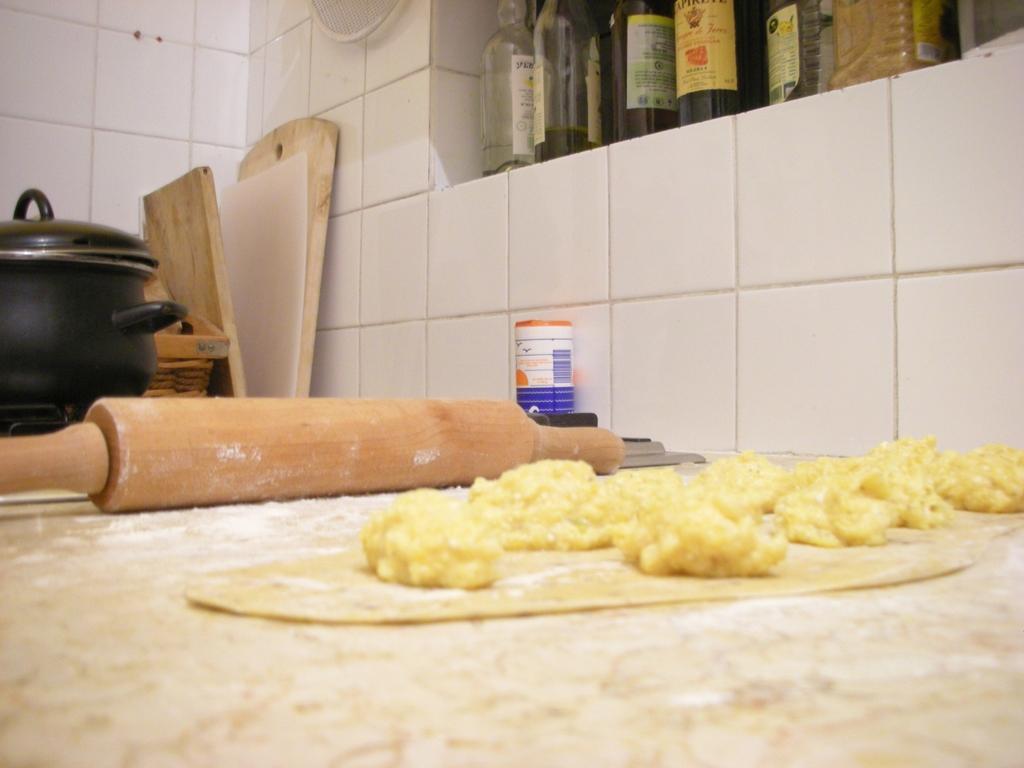Could you give a brief overview of what you see in this image? In this image there are food items on the platform. There is a roller and there are a few other objects. There is a cooker on the stove. Behind the cooker there are some wooden objects. There are bottles on the platform. In the background of the image there is a tile wall. There is some white color object on the wall. 